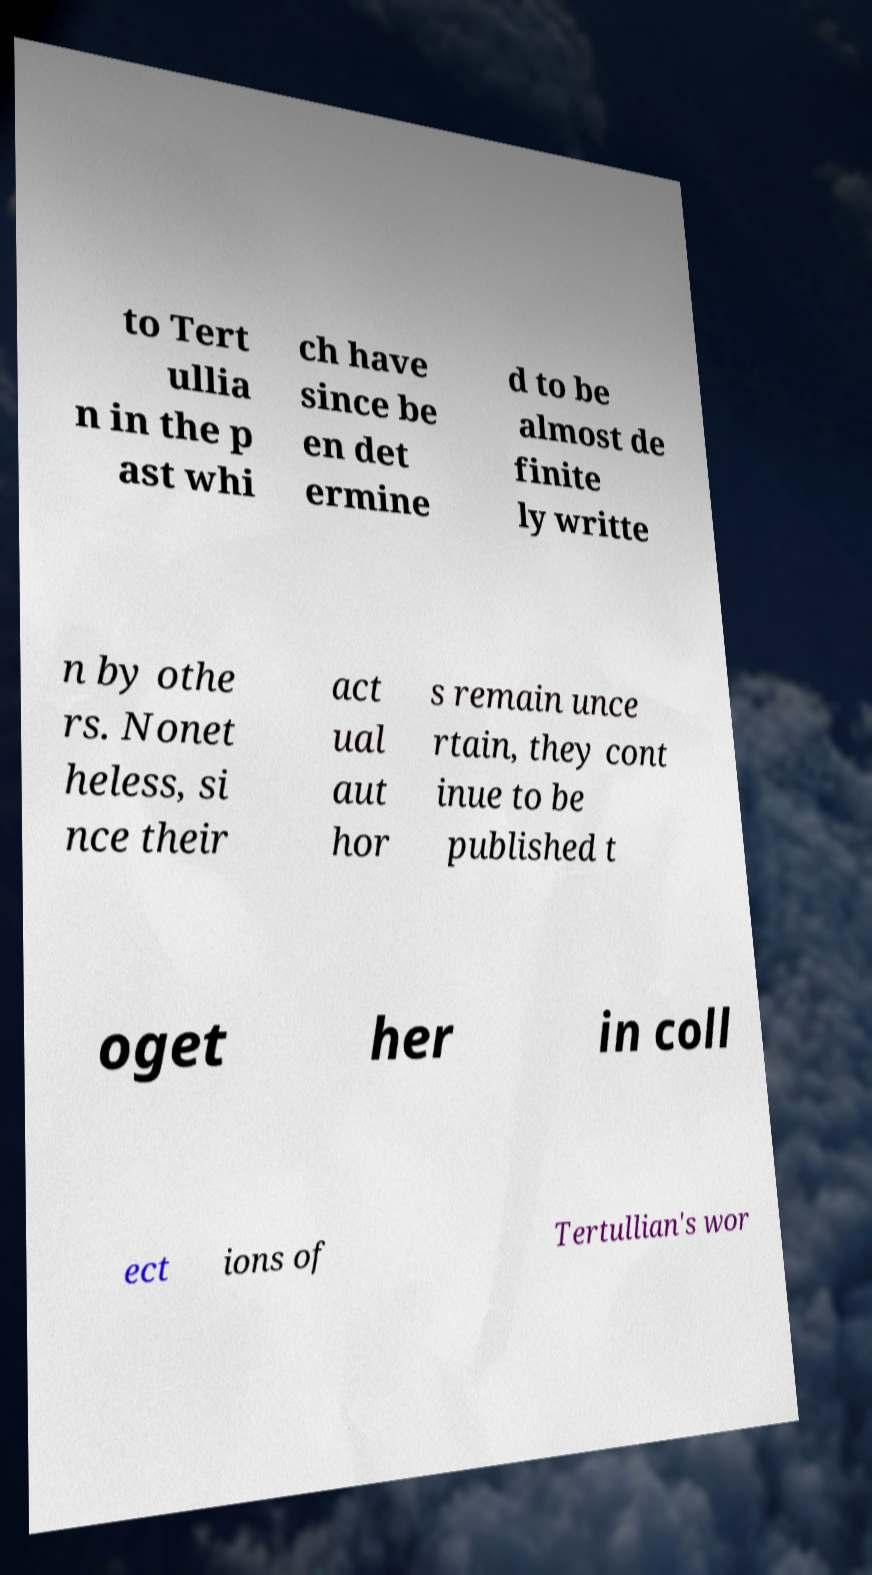Please identify and transcribe the text found in this image. to Tert ullia n in the p ast whi ch have since be en det ermine d to be almost de finite ly writte n by othe rs. Nonet heless, si nce their act ual aut hor s remain unce rtain, they cont inue to be published t oget her in coll ect ions of Tertullian's wor 